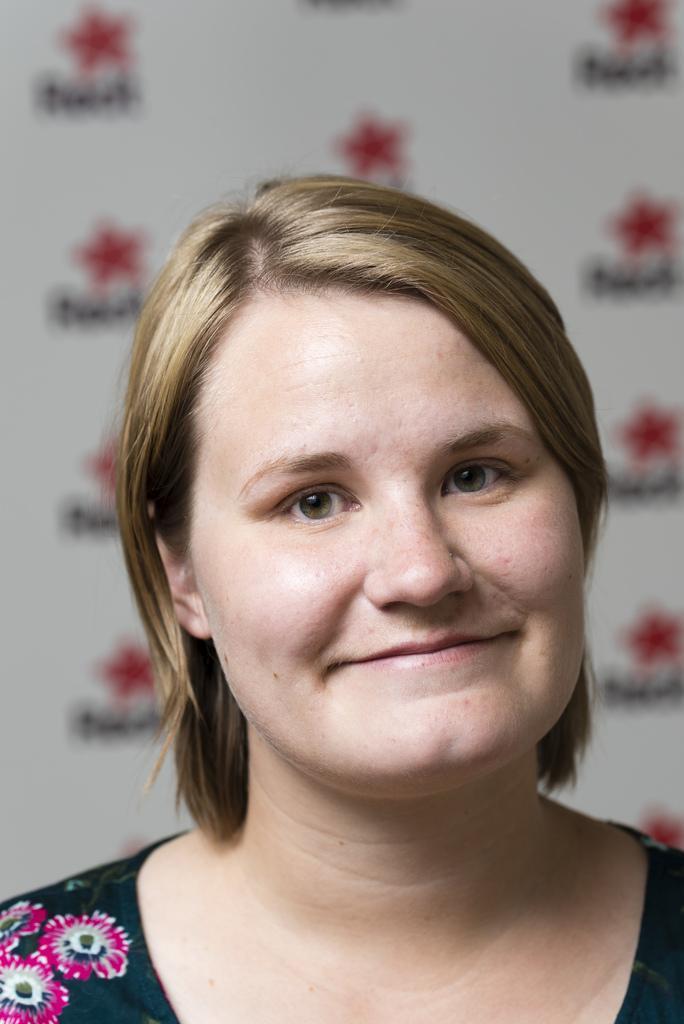How would you summarize this image in a sentence or two? There is a woman smiling. In the background we can see hoarding. 